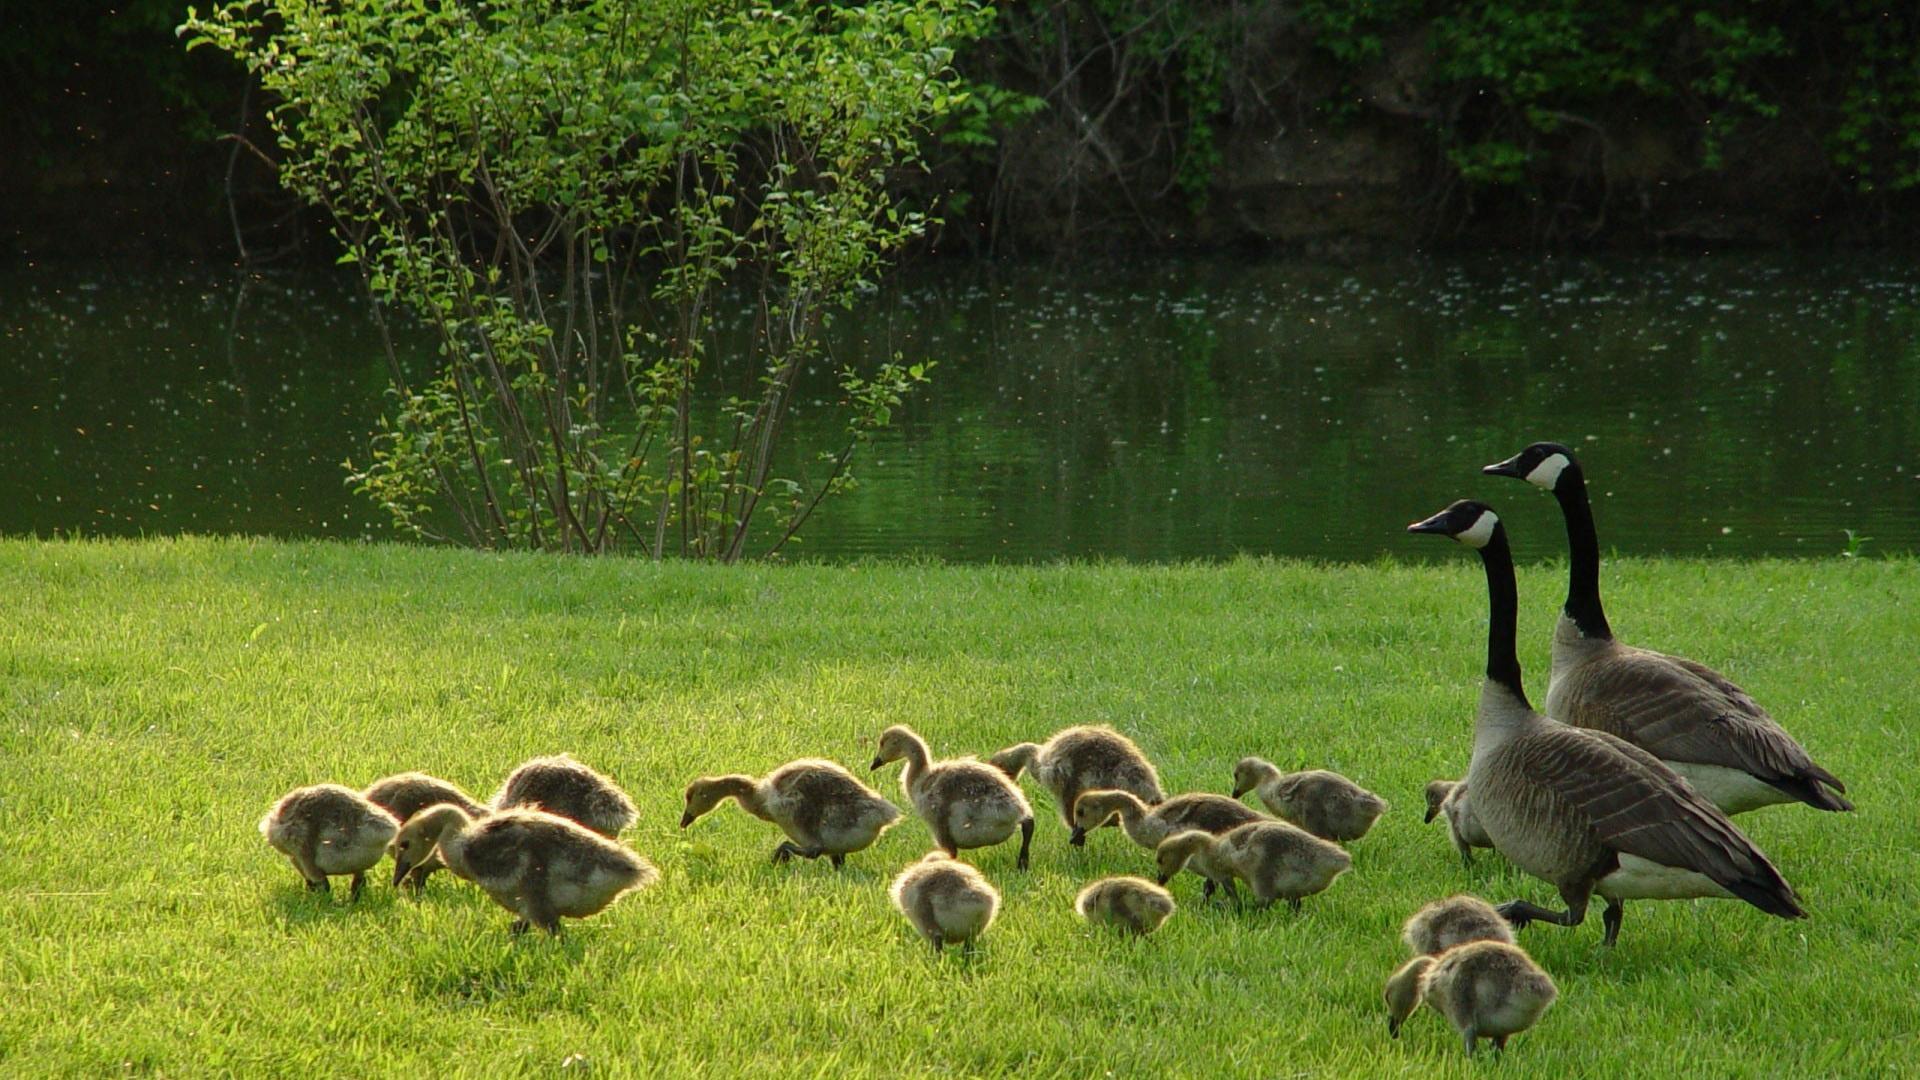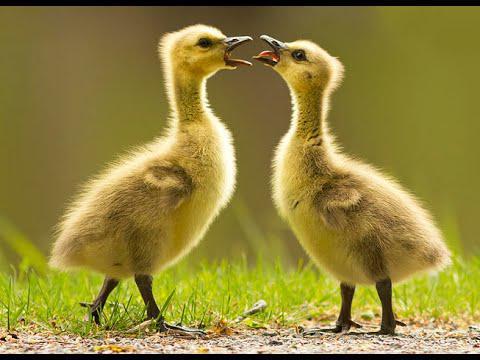The first image is the image on the left, the second image is the image on the right. For the images displayed, is the sentence "two parents are swimming with their baby geese." factually correct? Answer yes or no. No. The first image is the image on the left, the second image is the image on the right. Considering the images on both sides, is "The ducks are swimming in at least one of the images." valid? Answer yes or no. No. 